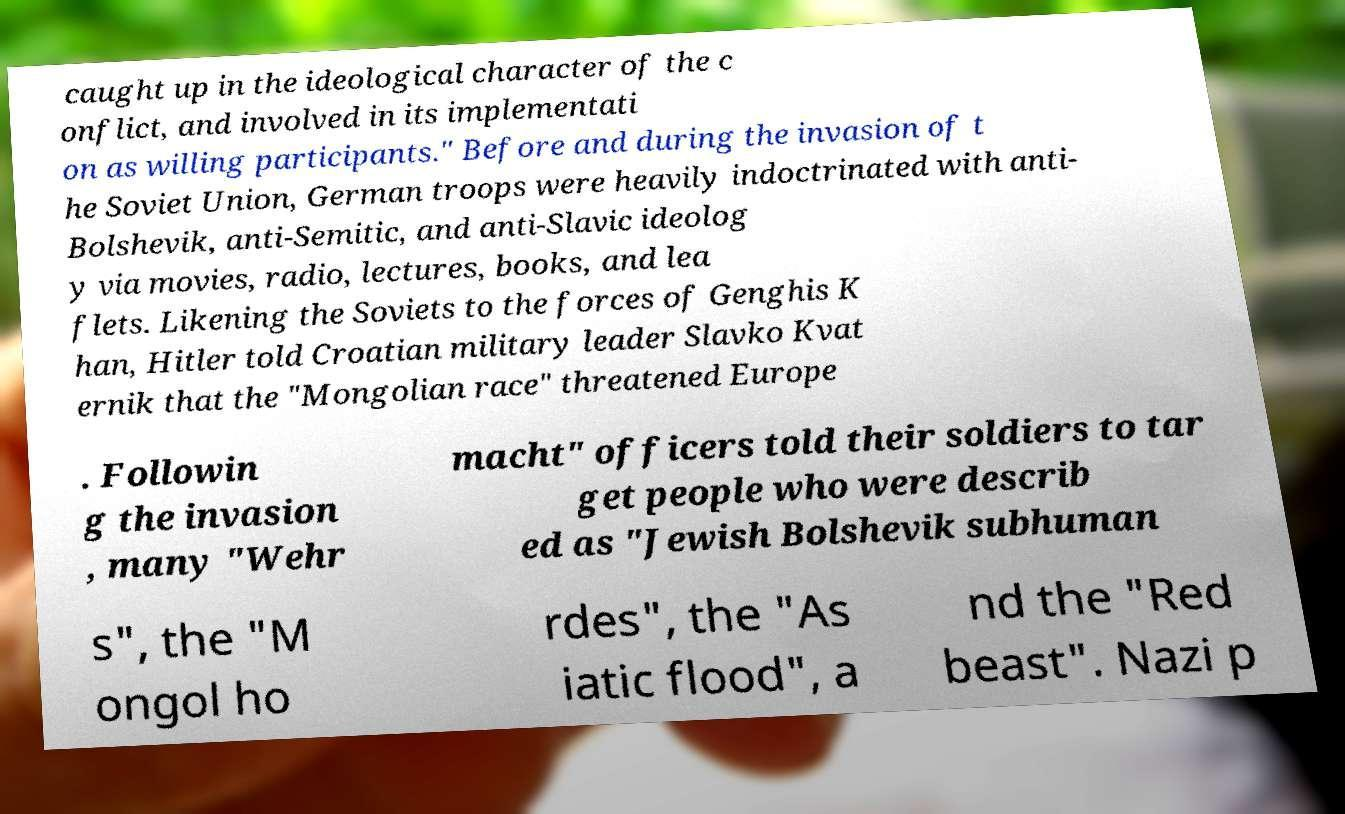I need the written content from this picture converted into text. Can you do that? caught up in the ideological character of the c onflict, and involved in its implementati on as willing participants." Before and during the invasion of t he Soviet Union, German troops were heavily indoctrinated with anti- Bolshevik, anti-Semitic, and anti-Slavic ideolog y via movies, radio, lectures, books, and lea flets. Likening the Soviets to the forces of Genghis K han, Hitler told Croatian military leader Slavko Kvat ernik that the "Mongolian race" threatened Europe . Followin g the invasion , many "Wehr macht" officers told their soldiers to tar get people who were describ ed as "Jewish Bolshevik subhuman s", the "M ongol ho rdes", the "As iatic flood", a nd the "Red beast". Nazi p 